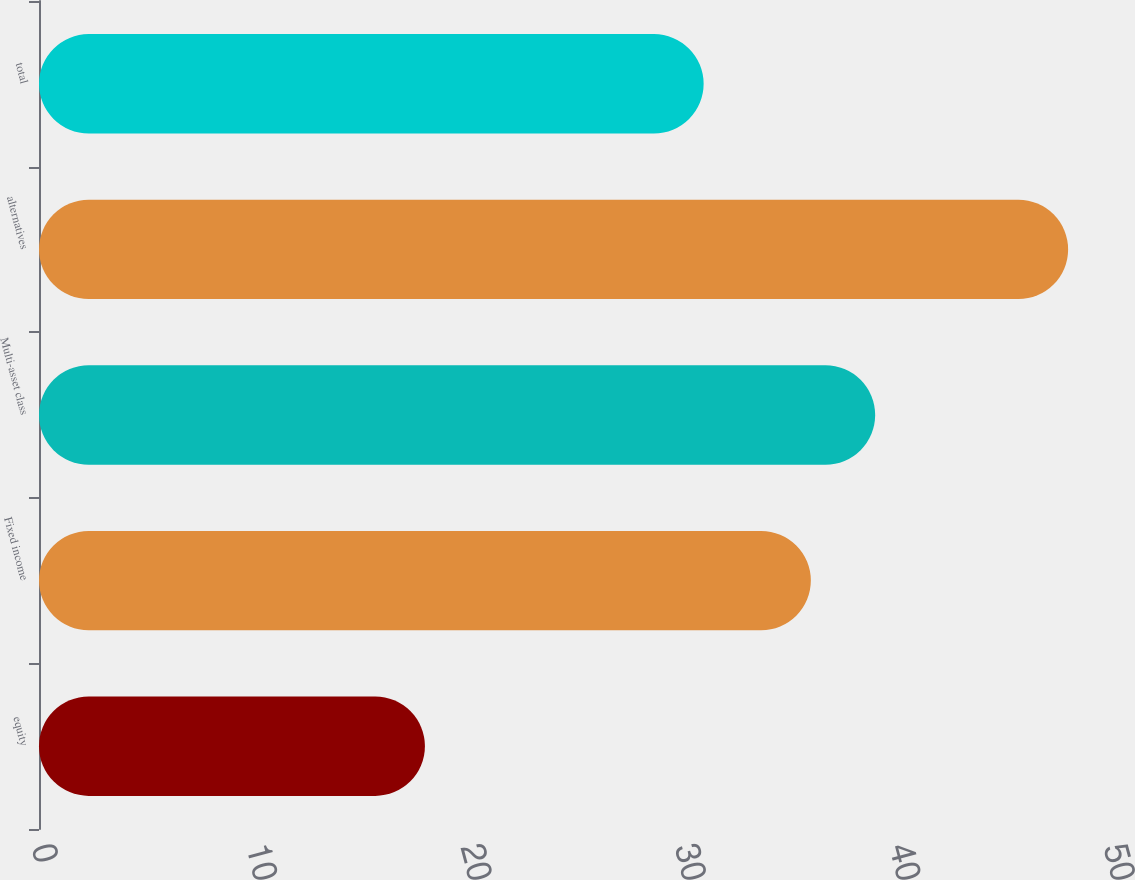Convert chart. <chart><loc_0><loc_0><loc_500><loc_500><bar_chart><fcel>equity<fcel>Fixed income<fcel>Multi-asset class<fcel>alternatives<fcel>total<nl><fcel>18<fcel>36<fcel>39<fcel>48<fcel>31<nl></chart> 